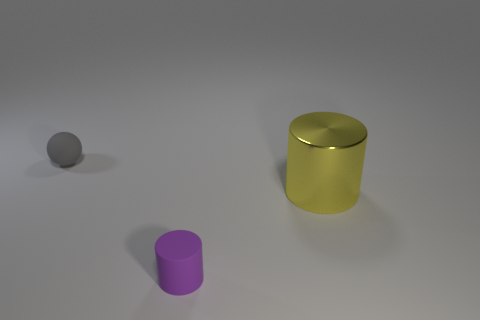Add 1 large objects. How many objects exist? 4 Subtract all balls. How many objects are left? 2 Subtract all tiny gray matte things. Subtract all matte things. How many objects are left? 0 Add 1 purple rubber cylinders. How many purple rubber cylinders are left? 2 Add 2 tiny spheres. How many tiny spheres exist? 3 Subtract 0 brown balls. How many objects are left? 3 